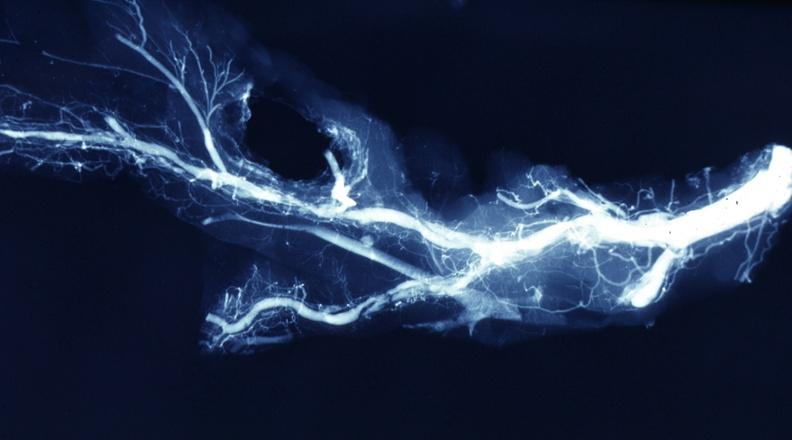what postmortdissected artery lesions in small branches?
Answer the question using a single word or phrase. X-ray 